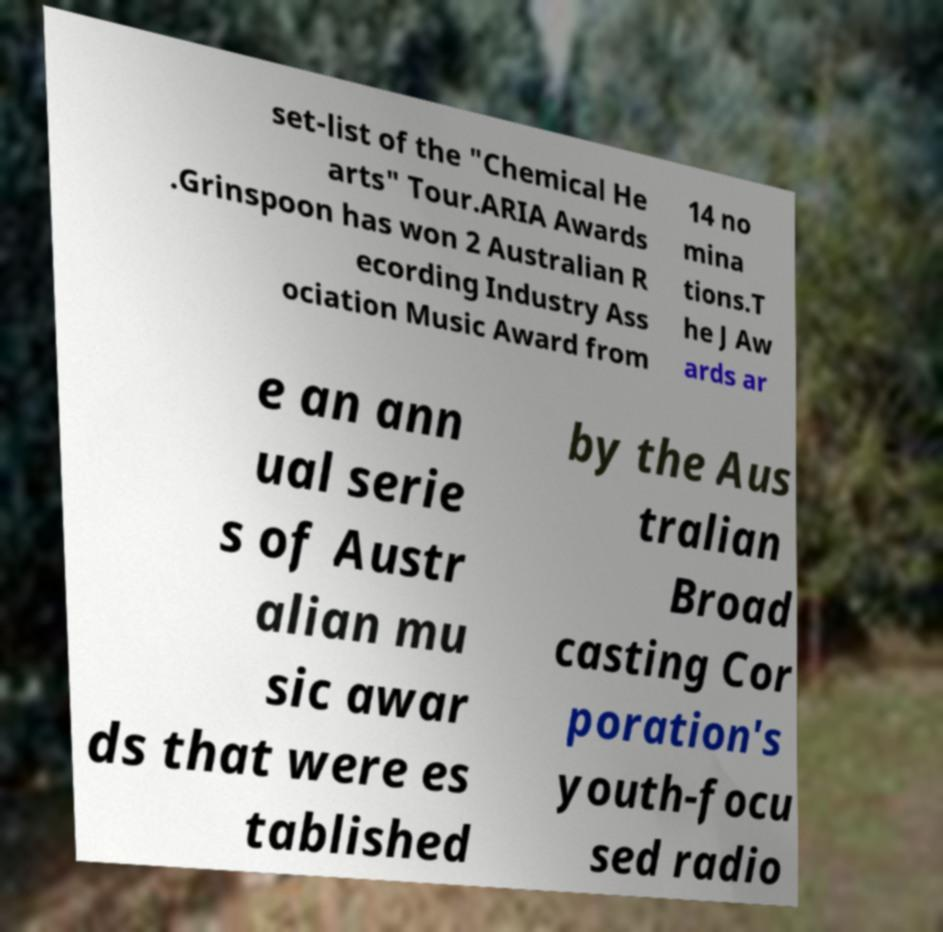There's text embedded in this image that I need extracted. Can you transcribe it verbatim? set-list of the "Chemical He arts" Tour.ARIA Awards .Grinspoon has won 2 Australian R ecording Industry Ass ociation Music Award from 14 no mina tions.T he J Aw ards ar e an ann ual serie s of Austr alian mu sic awar ds that were es tablished by the Aus tralian Broad casting Cor poration's youth-focu sed radio 